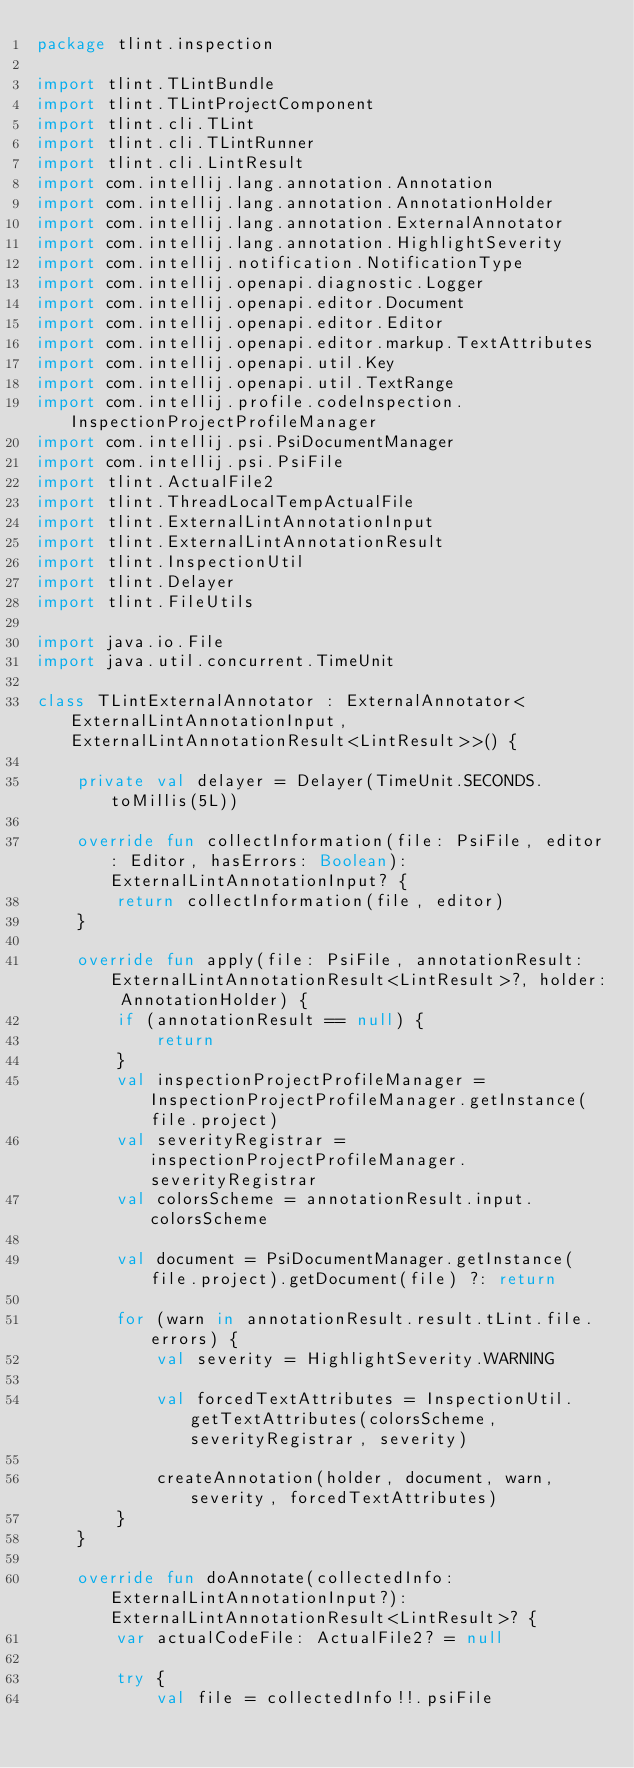Convert code to text. <code><loc_0><loc_0><loc_500><loc_500><_Kotlin_>package tlint.inspection

import tlint.TLintBundle
import tlint.TLintProjectComponent
import tlint.cli.TLint
import tlint.cli.TLintRunner
import tlint.cli.LintResult
import com.intellij.lang.annotation.Annotation
import com.intellij.lang.annotation.AnnotationHolder
import com.intellij.lang.annotation.ExternalAnnotator
import com.intellij.lang.annotation.HighlightSeverity
import com.intellij.notification.NotificationType
import com.intellij.openapi.diagnostic.Logger
import com.intellij.openapi.editor.Document
import com.intellij.openapi.editor.Editor
import com.intellij.openapi.editor.markup.TextAttributes
import com.intellij.openapi.util.Key
import com.intellij.openapi.util.TextRange
import com.intellij.profile.codeInspection.InspectionProjectProfileManager
import com.intellij.psi.PsiDocumentManager
import com.intellij.psi.PsiFile
import tlint.ActualFile2
import tlint.ThreadLocalTempActualFile
import tlint.ExternalLintAnnotationInput
import tlint.ExternalLintAnnotationResult
import tlint.InspectionUtil
import tlint.Delayer
import tlint.FileUtils

import java.io.File
import java.util.concurrent.TimeUnit

class TLintExternalAnnotator : ExternalAnnotator<ExternalLintAnnotationInput, ExternalLintAnnotationResult<LintResult>>() {

    private val delayer = Delayer(TimeUnit.SECONDS.toMillis(5L))

    override fun collectInformation(file: PsiFile, editor: Editor, hasErrors: Boolean): ExternalLintAnnotationInput? {
        return collectInformation(file, editor)
    }

    override fun apply(file: PsiFile, annotationResult: ExternalLintAnnotationResult<LintResult>?, holder: AnnotationHolder) {
        if (annotationResult == null) {
            return
        }
        val inspectionProjectProfileManager = InspectionProjectProfileManager.getInstance(file.project)
        val severityRegistrar = inspectionProjectProfileManager.severityRegistrar
        val colorsScheme = annotationResult.input.colorsScheme

        val document = PsiDocumentManager.getInstance(file.project).getDocument(file) ?: return

        for (warn in annotationResult.result.tLint.file.errors) {
            val severity = HighlightSeverity.WARNING

            val forcedTextAttributes = InspectionUtil.getTextAttributes(colorsScheme, severityRegistrar, severity)

            createAnnotation(holder, document, warn, severity, forcedTextAttributes)
        }
    }

    override fun doAnnotate(collectedInfo: ExternalLintAnnotationInput?): ExternalLintAnnotationResult<LintResult>? {
        var actualCodeFile: ActualFile2? = null

        try {
            val file = collectedInfo!!.psiFile
</code> 